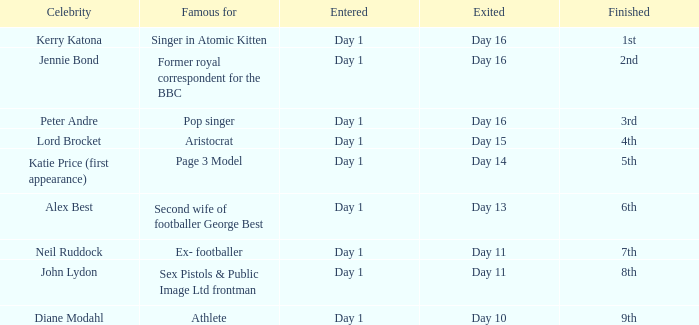Name the number of celebrity for athlete 1.0. 